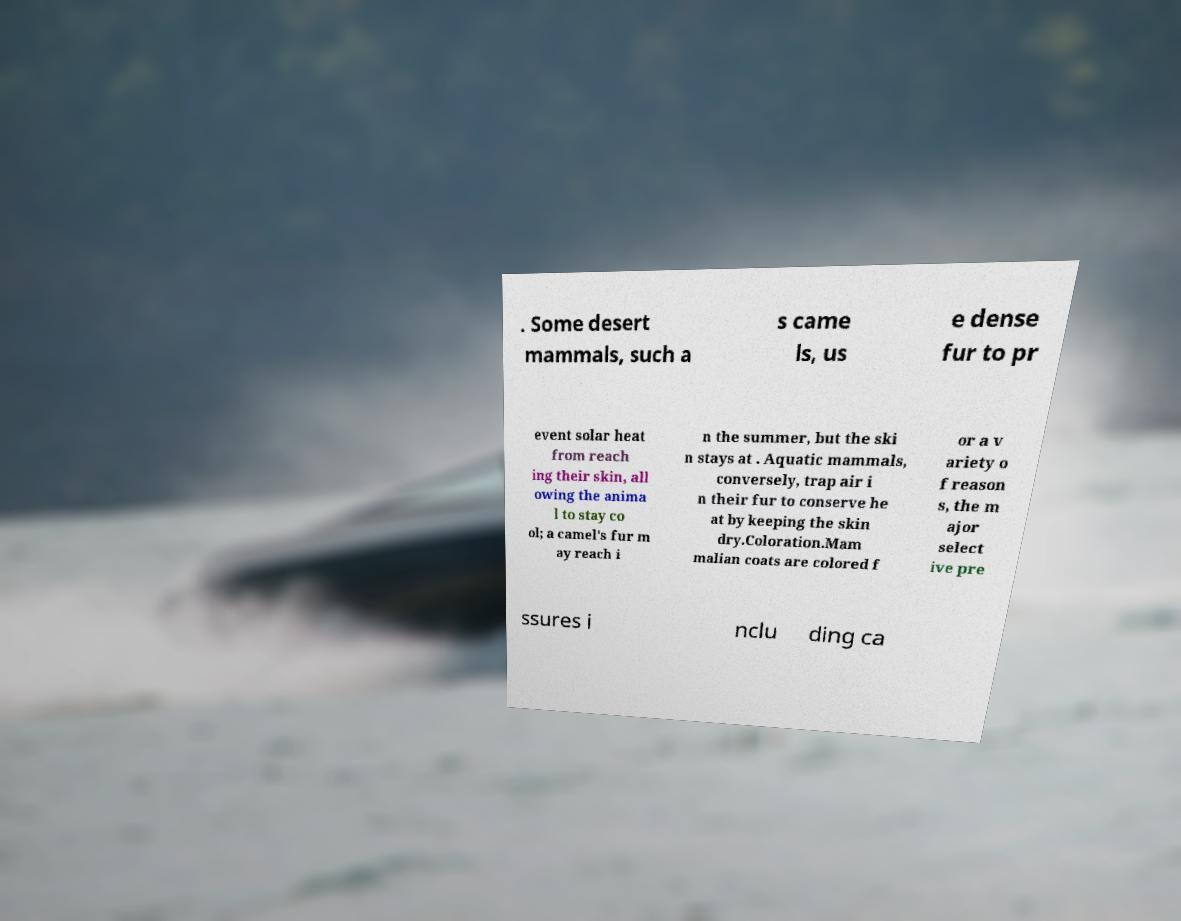What messages or text are displayed in this image? I need them in a readable, typed format. . Some desert mammals, such a s came ls, us e dense fur to pr event solar heat from reach ing their skin, all owing the anima l to stay co ol; a camel's fur m ay reach i n the summer, but the ski n stays at . Aquatic mammals, conversely, trap air i n their fur to conserve he at by keeping the skin dry.Coloration.Mam malian coats are colored f or a v ariety o f reason s, the m ajor select ive pre ssures i nclu ding ca 